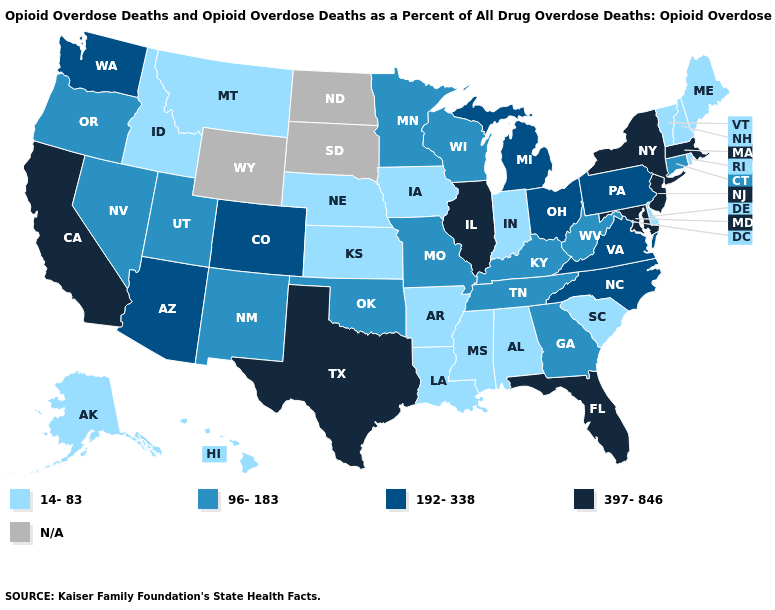Name the states that have a value in the range 14-83?
Write a very short answer. Alabama, Alaska, Arkansas, Delaware, Hawaii, Idaho, Indiana, Iowa, Kansas, Louisiana, Maine, Mississippi, Montana, Nebraska, New Hampshire, Rhode Island, South Carolina, Vermont. Name the states that have a value in the range N/A?
Concise answer only. North Dakota, South Dakota, Wyoming. Does Kentucky have the lowest value in the USA?
Short answer required. No. Which states have the lowest value in the USA?
Short answer required. Alabama, Alaska, Arkansas, Delaware, Hawaii, Idaho, Indiana, Iowa, Kansas, Louisiana, Maine, Mississippi, Montana, Nebraska, New Hampshire, Rhode Island, South Carolina, Vermont. Name the states that have a value in the range 96-183?
Concise answer only. Connecticut, Georgia, Kentucky, Minnesota, Missouri, Nevada, New Mexico, Oklahoma, Oregon, Tennessee, Utah, West Virginia, Wisconsin. What is the value of Arkansas?
Keep it brief. 14-83. What is the lowest value in the MidWest?
Answer briefly. 14-83. What is the value of Ohio?
Concise answer only. 192-338. Name the states that have a value in the range 192-338?
Keep it brief. Arizona, Colorado, Michigan, North Carolina, Ohio, Pennsylvania, Virginia, Washington. What is the value of Illinois?
Write a very short answer. 397-846. What is the value of New Hampshire?
Give a very brief answer. 14-83. What is the lowest value in the USA?
Keep it brief. 14-83. What is the highest value in the USA?
Answer briefly. 397-846. Does Rhode Island have the lowest value in the Northeast?
Give a very brief answer. Yes. Does South Carolina have the lowest value in the USA?
Short answer required. Yes. 